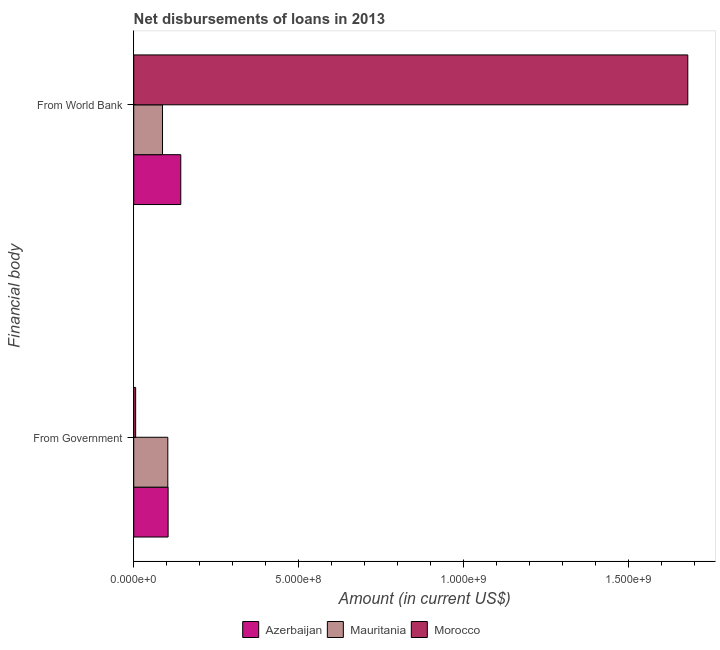How many different coloured bars are there?
Keep it short and to the point. 3. How many groups of bars are there?
Make the answer very short. 2. How many bars are there on the 1st tick from the top?
Provide a short and direct response. 3. What is the label of the 1st group of bars from the top?
Your answer should be very brief. From World Bank. What is the net disbursements of loan from world bank in Mauritania?
Provide a short and direct response. 8.72e+07. Across all countries, what is the maximum net disbursements of loan from world bank?
Ensure brevity in your answer.  1.68e+09. Across all countries, what is the minimum net disbursements of loan from government?
Your response must be concise. 5.81e+06. In which country was the net disbursements of loan from government maximum?
Your answer should be compact. Azerbaijan. In which country was the net disbursements of loan from government minimum?
Provide a short and direct response. Morocco. What is the total net disbursements of loan from government in the graph?
Give a very brief answer. 2.13e+08. What is the difference between the net disbursements of loan from government in Morocco and that in Azerbaijan?
Your answer should be very brief. -9.83e+07. What is the difference between the net disbursements of loan from world bank in Morocco and the net disbursements of loan from government in Azerbaijan?
Provide a succinct answer. 1.57e+09. What is the average net disbursements of loan from government per country?
Provide a short and direct response. 7.11e+07. What is the difference between the net disbursements of loan from government and net disbursements of loan from world bank in Morocco?
Offer a terse response. -1.67e+09. In how many countries, is the net disbursements of loan from world bank greater than 600000000 US$?
Provide a succinct answer. 1. What is the ratio of the net disbursements of loan from government in Mauritania to that in Morocco?
Your answer should be very brief. 17.76. What does the 3rd bar from the top in From Government represents?
Make the answer very short. Azerbaijan. What does the 2nd bar from the bottom in From World Bank represents?
Your response must be concise. Mauritania. How many bars are there?
Provide a succinct answer. 6. Are all the bars in the graph horizontal?
Offer a terse response. Yes. Are the values on the major ticks of X-axis written in scientific E-notation?
Keep it short and to the point. Yes. What is the title of the graph?
Offer a very short reply. Net disbursements of loans in 2013. Does "Gambia, The" appear as one of the legend labels in the graph?
Give a very brief answer. No. What is the label or title of the Y-axis?
Keep it short and to the point. Financial body. What is the Amount (in current US$) of Azerbaijan in From Government?
Your answer should be compact. 1.04e+08. What is the Amount (in current US$) in Mauritania in From Government?
Offer a very short reply. 1.03e+08. What is the Amount (in current US$) in Morocco in From Government?
Offer a very short reply. 5.81e+06. What is the Amount (in current US$) in Azerbaijan in From World Bank?
Your answer should be very brief. 1.43e+08. What is the Amount (in current US$) in Mauritania in From World Bank?
Make the answer very short. 8.72e+07. What is the Amount (in current US$) in Morocco in From World Bank?
Make the answer very short. 1.68e+09. Across all Financial body, what is the maximum Amount (in current US$) in Azerbaijan?
Make the answer very short. 1.43e+08. Across all Financial body, what is the maximum Amount (in current US$) of Mauritania?
Provide a short and direct response. 1.03e+08. Across all Financial body, what is the maximum Amount (in current US$) of Morocco?
Offer a very short reply. 1.68e+09. Across all Financial body, what is the minimum Amount (in current US$) in Azerbaijan?
Give a very brief answer. 1.04e+08. Across all Financial body, what is the minimum Amount (in current US$) of Mauritania?
Make the answer very short. 8.72e+07. Across all Financial body, what is the minimum Amount (in current US$) in Morocco?
Your answer should be very brief. 5.81e+06. What is the total Amount (in current US$) in Azerbaijan in the graph?
Your answer should be very brief. 2.47e+08. What is the total Amount (in current US$) of Mauritania in the graph?
Provide a short and direct response. 1.90e+08. What is the total Amount (in current US$) in Morocco in the graph?
Ensure brevity in your answer.  1.68e+09. What is the difference between the Amount (in current US$) of Azerbaijan in From Government and that in From World Bank?
Give a very brief answer. -3.84e+07. What is the difference between the Amount (in current US$) in Mauritania in From Government and that in From World Bank?
Make the answer very short. 1.61e+07. What is the difference between the Amount (in current US$) in Morocco in From Government and that in From World Bank?
Provide a short and direct response. -1.67e+09. What is the difference between the Amount (in current US$) of Azerbaijan in From Government and the Amount (in current US$) of Mauritania in From World Bank?
Keep it short and to the point. 1.70e+07. What is the difference between the Amount (in current US$) of Azerbaijan in From Government and the Amount (in current US$) of Morocco in From World Bank?
Provide a succinct answer. -1.57e+09. What is the difference between the Amount (in current US$) of Mauritania in From Government and the Amount (in current US$) of Morocco in From World Bank?
Provide a short and direct response. -1.58e+09. What is the average Amount (in current US$) of Azerbaijan per Financial body?
Keep it short and to the point. 1.23e+08. What is the average Amount (in current US$) of Mauritania per Financial body?
Offer a very short reply. 9.52e+07. What is the average Amount (in current US$) of Morocco per Financial body?
Your answer should be very brief. 8.42e+08. What is the difference between the Amount (in current US$) of Azerbaijan and Amount (in current US$) of Mauritania in From Government?
Offer a very short reply. 8.99e+05. What is the difference between the Amount (in current US$) of Azerbaijan and Amount (in current US$) of Morocco in From Government?
Offer a very short reply. 9.83e+07. What is the difference between the Amount (in current US$) in Mauritania and Amount (in current US$) in Morocco in From Government?
Keep it short and to the point. 9.74e+07. What is the difference between the Amount (in current US$) of Azerbaijan and Amount (in current US$) of Mauritania in From World Bank?
Make the answer very short. 5.54e+07. What is the difference between the Amount (in current US$) in Azerbaijan and Amount (in current US$) in Morocco in From World Bank?
Provide a succinct answer. -1.54e+09. What is the difference between the Amount (in current US$) in Mauritania and Amount (in current US$) in Morocco in From World Bank?
Give a very brief answer. -1.59e+09. What is the ratio of the Amount (in current US$) of Azerbaijan in From Government to that in From World Bank?
Make the answer very short. 0.73. What is the ratio of the Amount (in current US$) in Mauritania in From Government to that in From World Bank?
Give a very brief answer. 1.18. What is the ratio of the Amount (in current US$) of Morocco in From Government to that in From World Bank?
Your answer should be very brief. 0. What is the difference between the highest and the second highest Amount (in current US$) of Azerbaijan?
Your answer should be very brief. 3.84e+07. What is the difference between the highest and the second highest Amount (in current US$) in Mauritania?
Your answer should be very brief. 1.61e+07. What is the difference between the highest and the second highest Amount (in current US$) in Morocco?
Offer a very short reply. 1.67e+09. What is the difference between the highest and the lowest Amount (in current US$) in Azerbaijan?
Your answer should be very brief. 3.84e+07. What is the difference between the highest and the lowest Amount (in current US$) of Mauritania?
Provide a short and direct response. 1.61e+07. What is the difference between the highest and the lowest Amount (in current US$) in Morocco?
Your answer should be compact. 1.67e+09. 